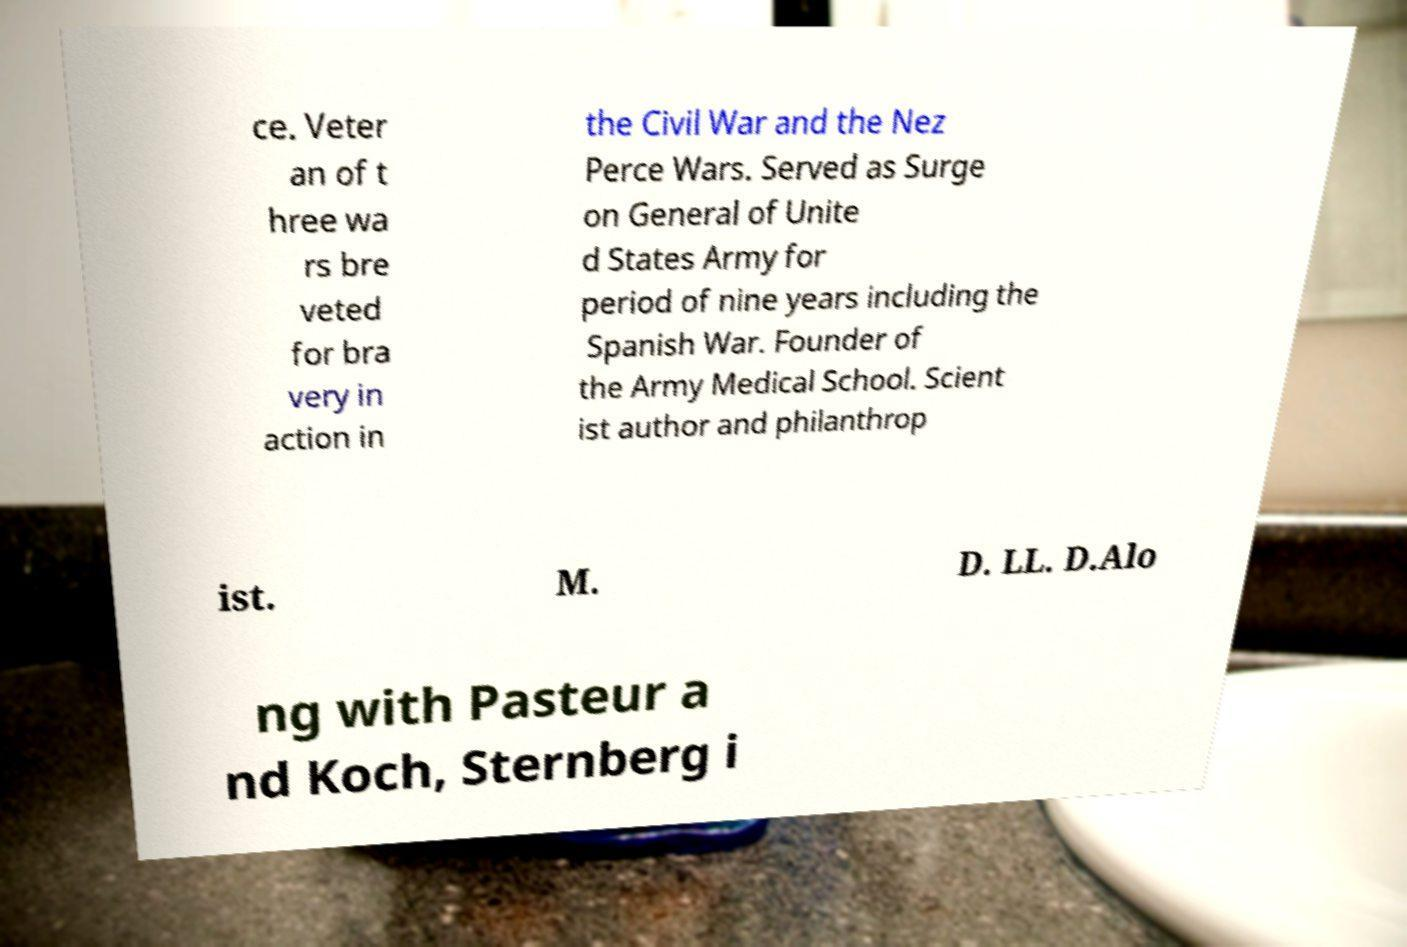Could you extract and type out the text from this image? ce. Veter an of t hree wa rs bre veted for bra very in action in the Civil War and the Nez Perce Wars. Served as Surge on General of Unite d States Army for period of nine years including the Spanish War. Founder of the Army Medical School. Scient ist author and philanthrop ist. M. D. LL. D.Alo ng with Pasteur a nd Koch, Sternberg i 